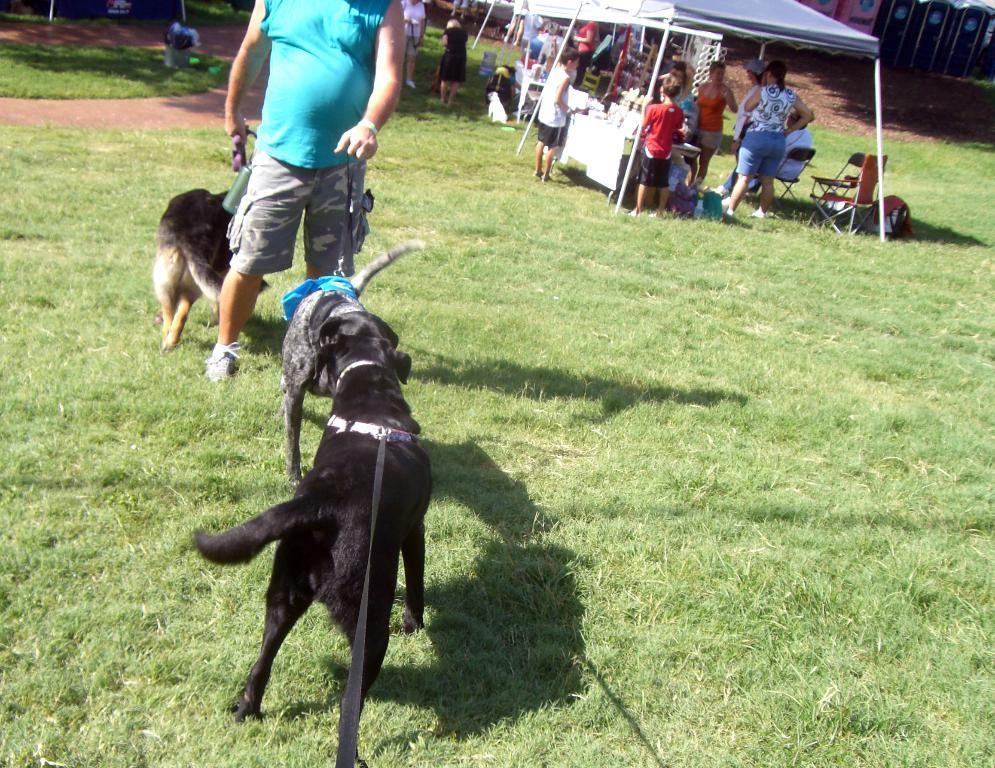Please provide a concise description of this image. In this picture there are a group of people standing here and there is a man standing here there are some dogs and in the background there are stalls. 